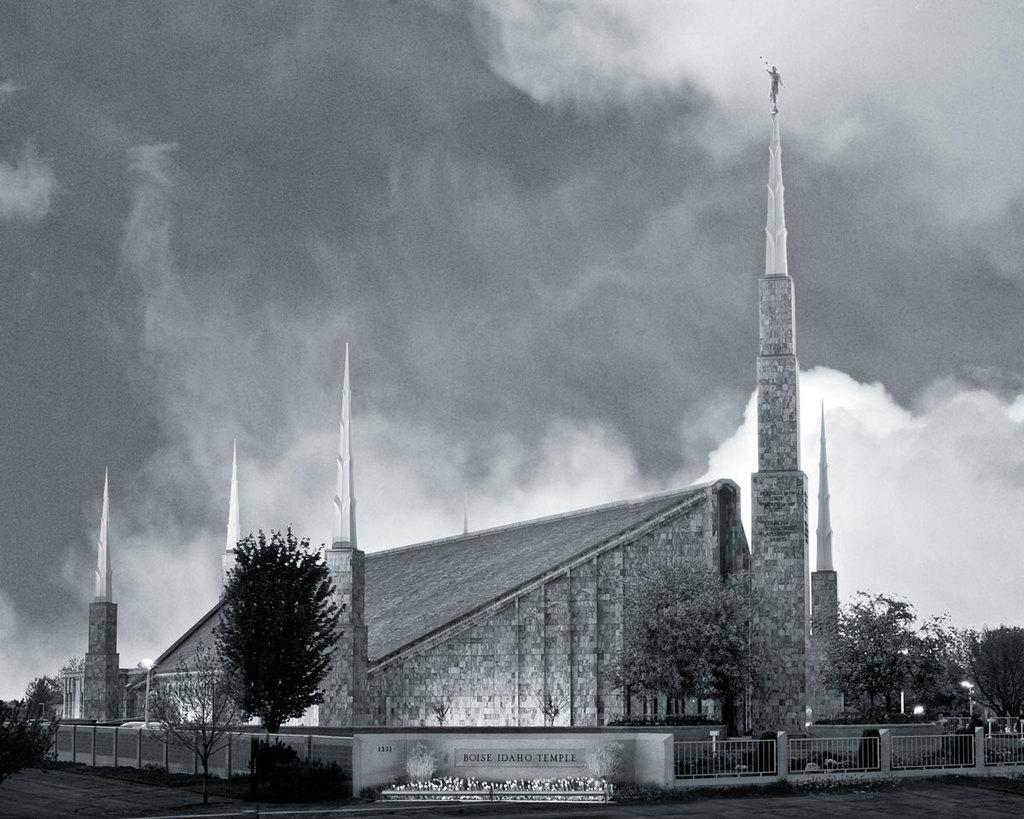What is the color scheme of the image? The image is black and white. What type of structure can be seen in the image? There is a building in the image. What other elements are present in the image besides the building? There are trees, pillars, a name board, and iron grilles in the image. What can be seen in the background of the image? The sky is visible in the background of the image. How many babies are wearing trousers in the image? There are no babies or trousers present in the image. What type of print is visible on the building in the image? There is no print visible on the building in the image; it is a black and white photograph. 